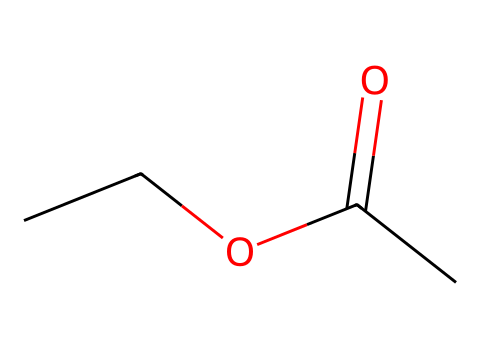What type of functional group is present in this compound? The compound features a carboxylate group (the C(=O)O part), indicating it is an ester.
Answer: ester How many carbon atoms are in this structure? Counting the carbon atoms in the structure, there are four carbon atoms present (C4).
Answer: 4 What is the saturation of the carbon chain? The structure contains a carbon chain with single bonds and one double bond (C=O), indicating it is saturated.
Answer: saturated What is the total number of hydrogen atoms in this molecule? The molecule contains 8 hydrogen atoms (derived from the hydrogen counts around each carbon in the structure).
Answer: 8 Which element does the ‘O’ represent in this compound? ‘O’ represents oxygen, which is present due to the ester functional group in this organic compound.
Answer: oxygen Is this compound likely to be polar or non-polar? The presence of the polar ester functional group suggests that the compound is likely polar.
Answer: polar What category of organic compounds does this molecule belong to? The overall structure and functional groups indicate that this compound is part of the ester category in organic chemistry.
Answer: ester 